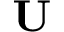<formula> <loc_0><loc_0><loc_500><loc_500>U</formula> 